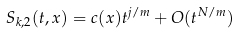Convert formula to latex. <formula><loc_0><loc_0><loc_500><loc_500>S _ { k , 2 } ( t , x ) = c ( x ) t ^ { j / m } + O ( t ^ { N / m } )</formula> 